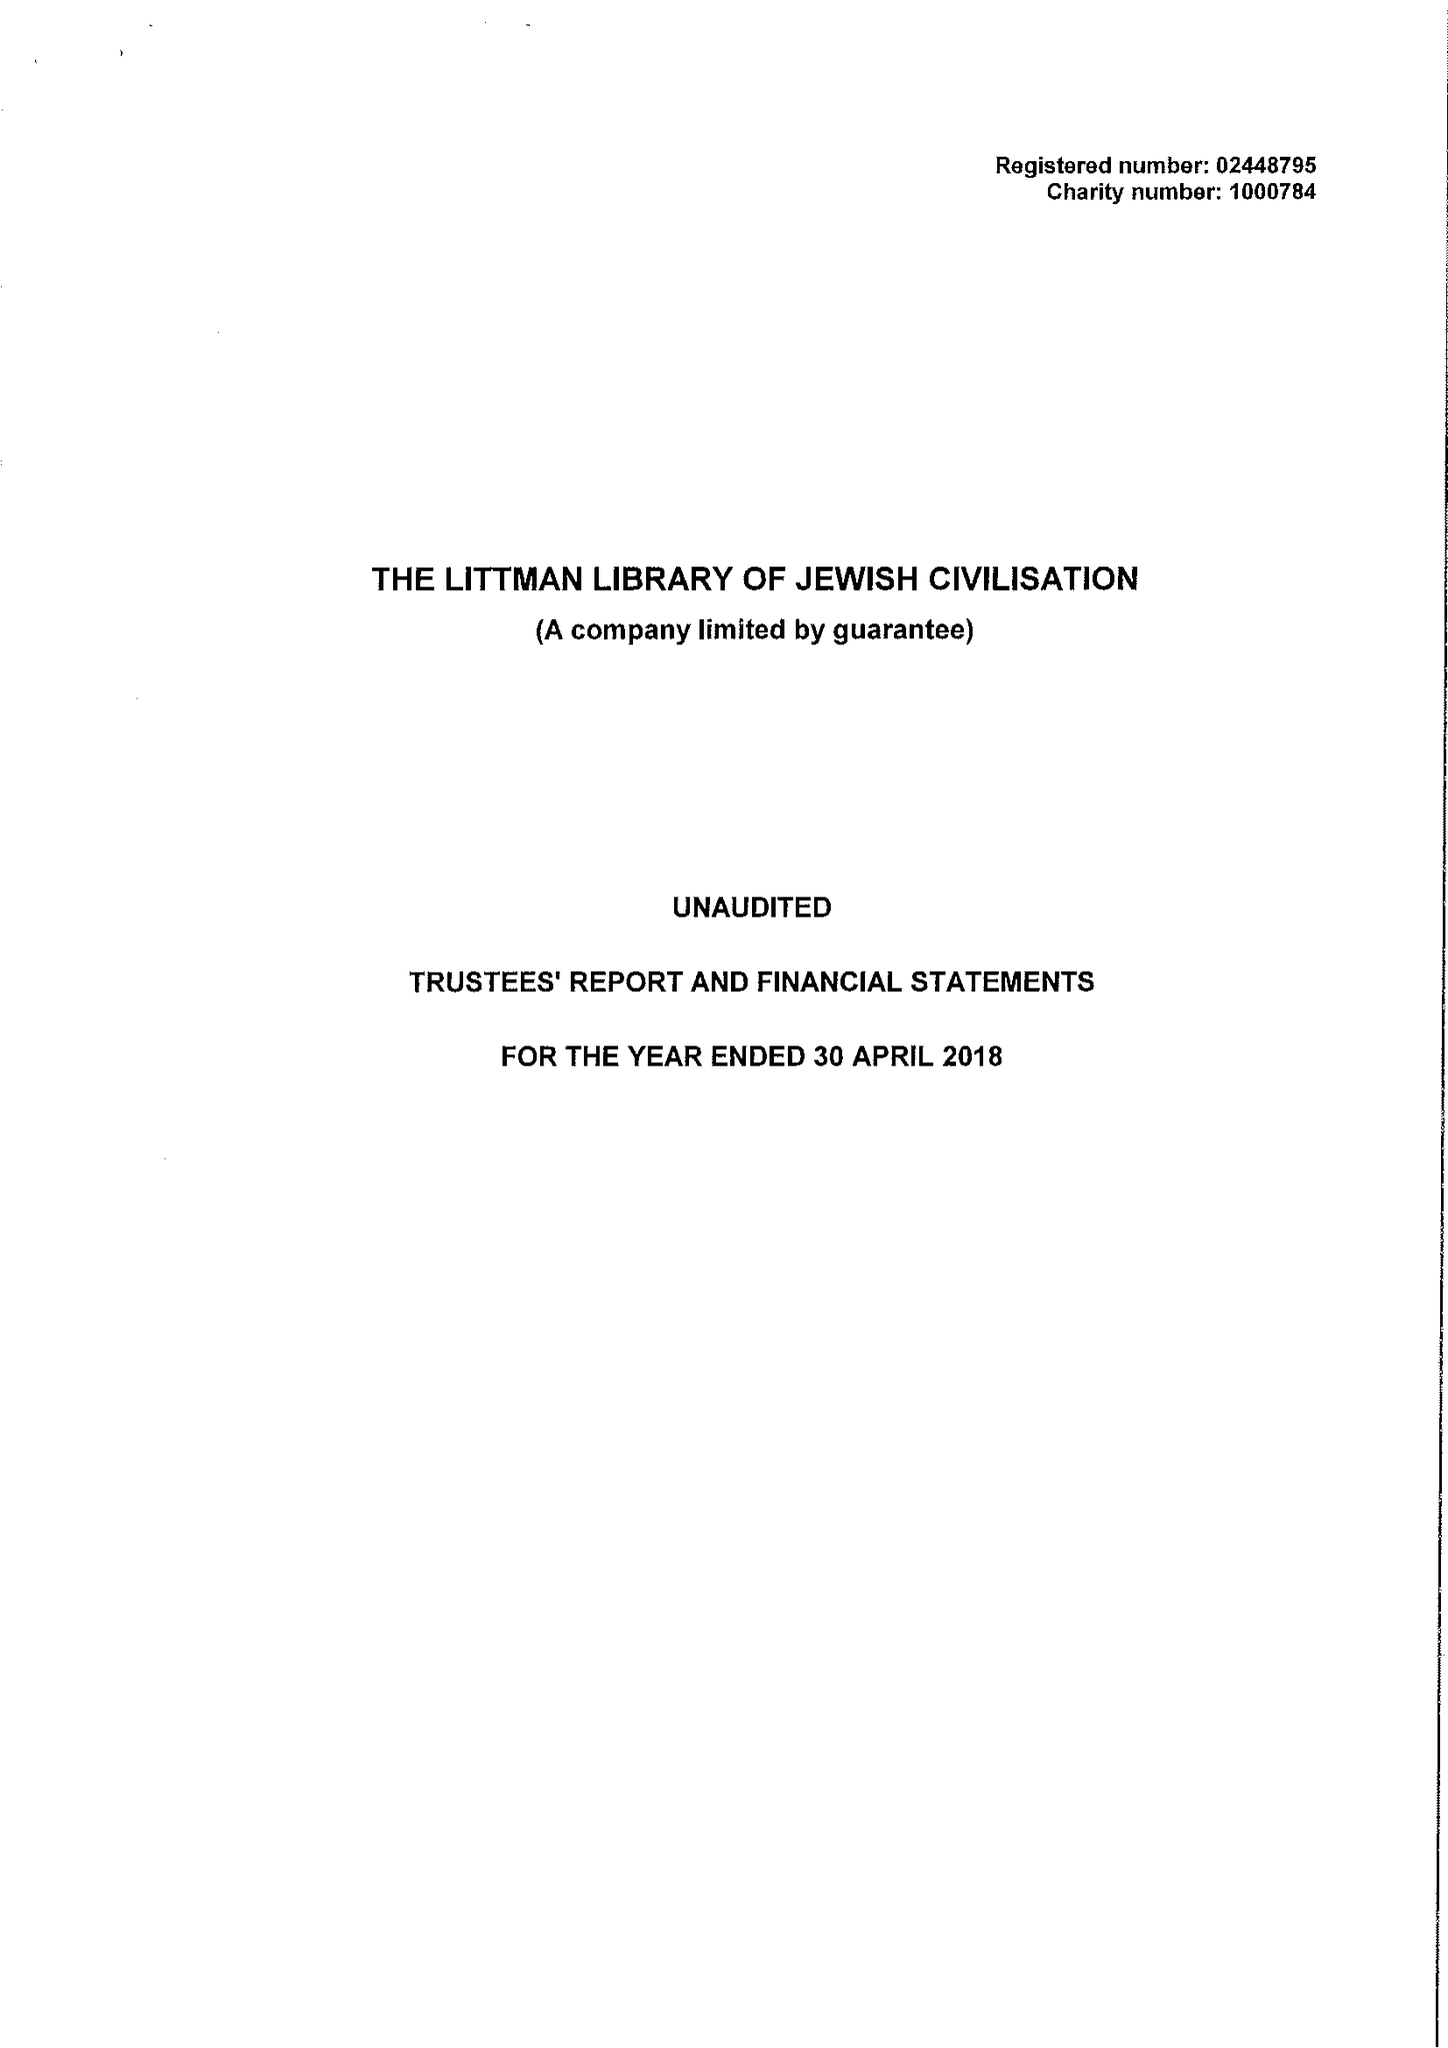What is the value for the address__postcode?
Answer the question using a single word or phrase. TA11 7BQ 